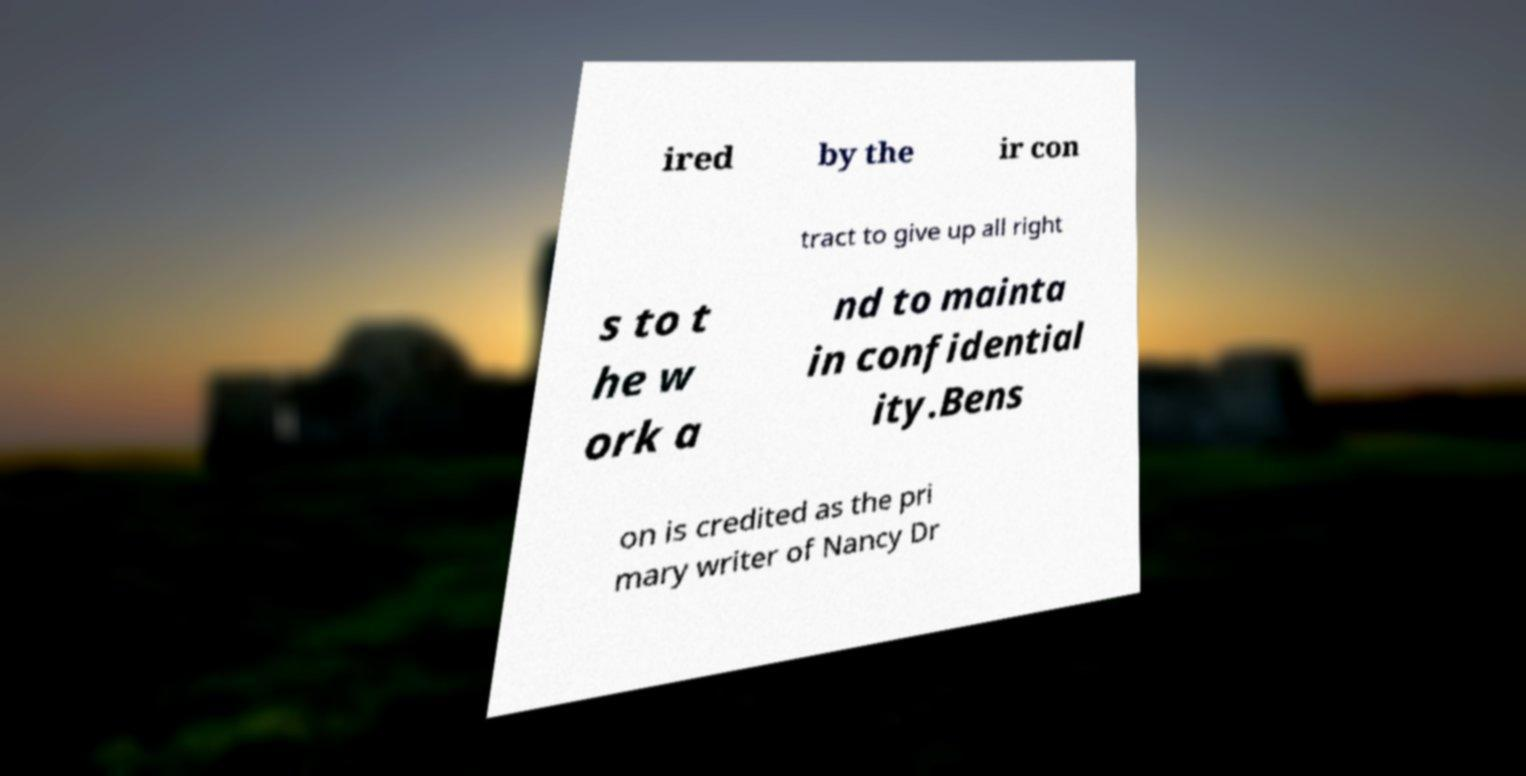Please read and relay the text visible in this image. What does it say? ired by the ir con tract to give up all right s to t he w ork a nd to mainta in confidential ity.Bens on is credited as the pri mary writer of Nancy Dr 